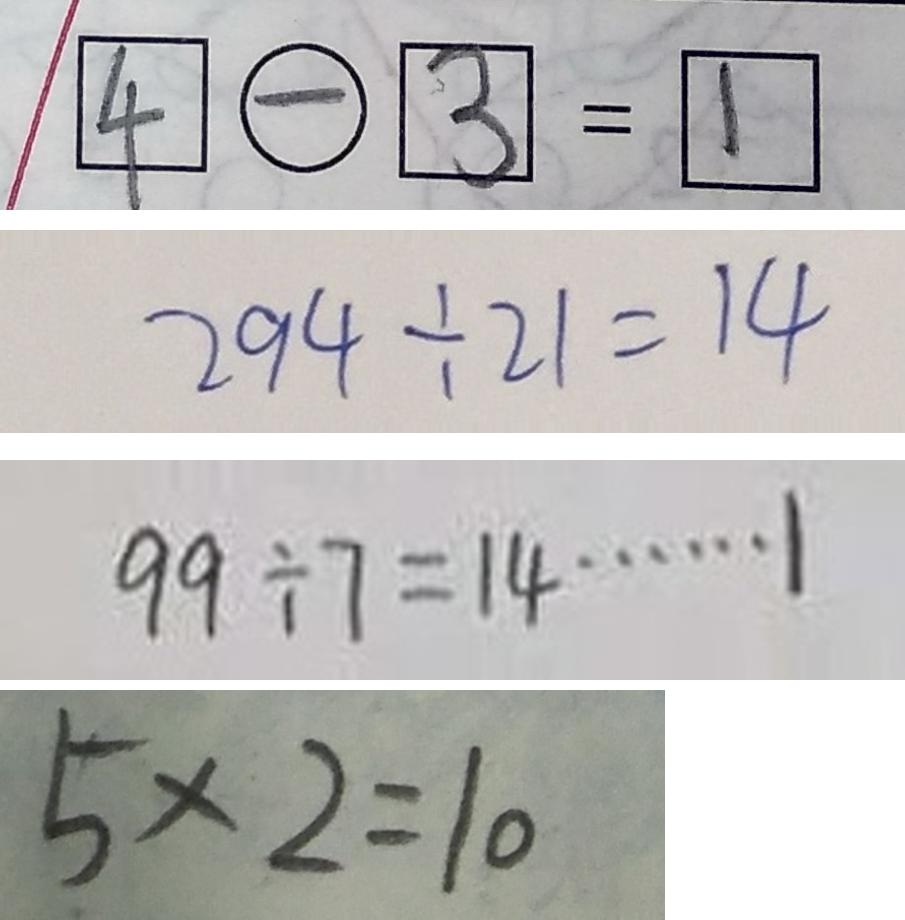<formula> <loc_0><loc_0><loc_500><loc_500>\boxed { 4 } \textcircled { - } \boxed { 3 } = \boxed { 1 } 
 2 9 4 \div 2 1 = 1 4 
 9 9 \div 7 = 1 4 \cdots 1 
 5 \times 2 = 1 0</formula> 